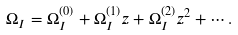Convert formula to latex. <formula><loc_0><loc_0><loc_500><loc_500>\Omega _ { I } = \Omega _ { I } ^ { ( 0 ) } + \Omega _ { I } ^ { ( 1 ) } z + \Omega _ { I } ^ { ( 2 ) } z ^ { 2 } + \cdots .</formula> 